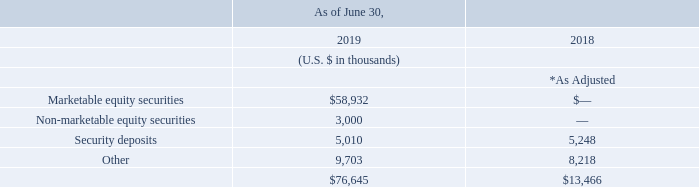Other non-current assets
Other non-current assets consisted of the following:
* As adjusted to reflect the impact of the full retrospective adoption of IFRS 15. See Note 2 for further details.
As of June 30, 2019 and 2018, the Group had certificates of deposit and time deposits totaling $3.7 million and $3.7 million which were classified as long-term and were included in security deposits. Included in the Group’s other non-current assets balance as of June 30, 2019 and 2018 were $7.1 million and $6.6 million respectively, of restricted cash used for commitments of standby letters of credit related to facility leases and were not available for the Group’s use in its operations.
As of June 30, 2019, what is the amount of certificates of deposit and time deposits? $3.7 million. What was the adjustment done to figures in 2018? To reflect the impact of the full retrospective adoption of ifrs 15. What is the total amount of non-current assets as of June 30, 2019?
Answer scale should be: thousand. $76,645. What is the change in value between security deposits between fiscal years 2018 and 2019?
Answer scale should be: thousand. 5,010-5,248
Answer: -238. What is the percentage difference of security deposits between fiscal years 2018 and 2019?
Answer scale should be: percent. (5,010-5,248)/5,248
Answer: -4.54. What is the percentage constitution of marketable equity securities among the total non-current assets in fiscal year 2019?
Answer scale should be: percent. 58,932/76,645
Answer: 76.89. 